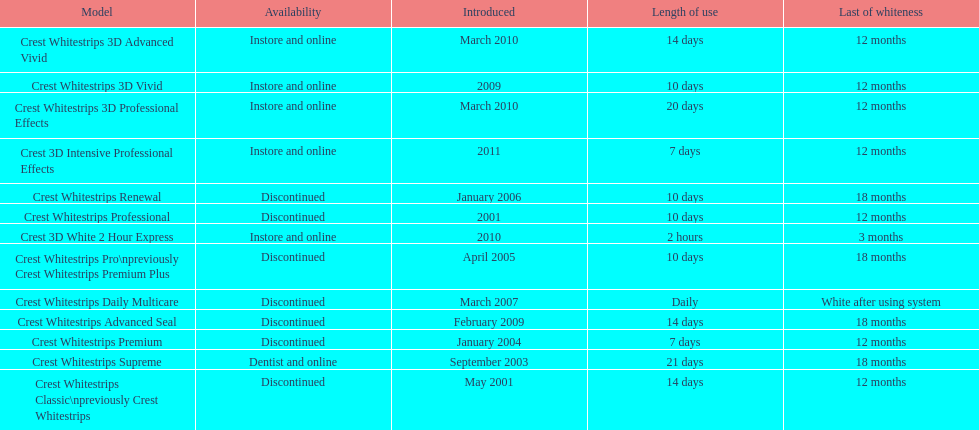What is the number of products that were introduced in 2010? 3. 